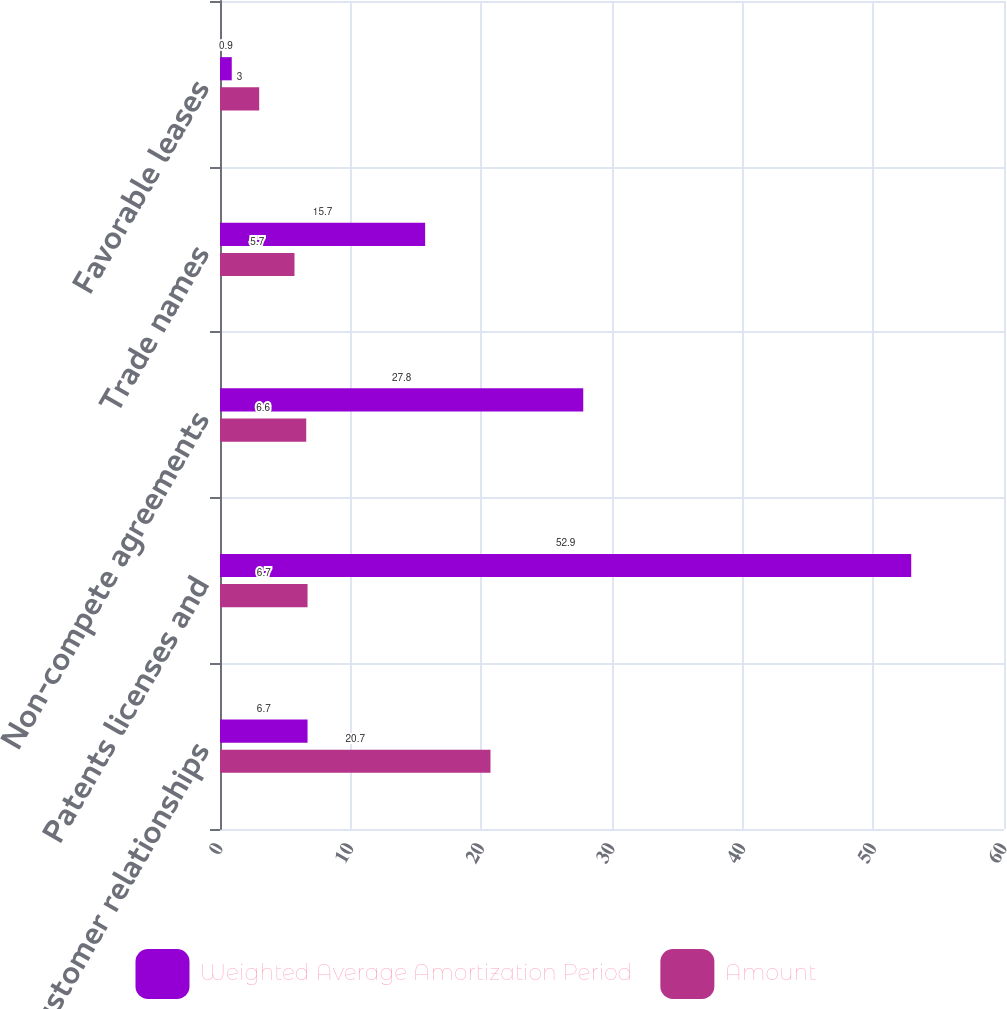Convert chart. <chart><loc_0><loc_0><loc_500><loc_500><stacked_bar_chart><ecel><fcel>Customer relationships<fcel>Patents licenses and<fcel>Non-compete agreements<fcel>Trade names<fcel>Favorable leases<nl><fcel>Weighted Average Amortization Period<fcel>6.7<fcel>52.9<fcel>27.8<fcel>15.7<fcel>0.9<nl><fcel>Amount<fcel>20.7<fcel>6.7<fcel>6.6<fcel>5.7<fcel>3<nl></chart> 